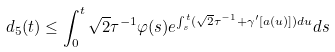Convert formula to latex. <formula><loc_0><loc_0><loc_500><loc_500>d _ { 5 } ( t ) \leq \int _ { 0 } ^ { t } \sqrt { 2 } \tau ^ { - 1 } \varphi ( s ) e ^ { \int _ { s } ^ { t } ( \sqrt { 2 } \tau ^ { - 1 } + \gamma ^ { \prime } [ a ( u ) ] ) d u } d s</formula> 